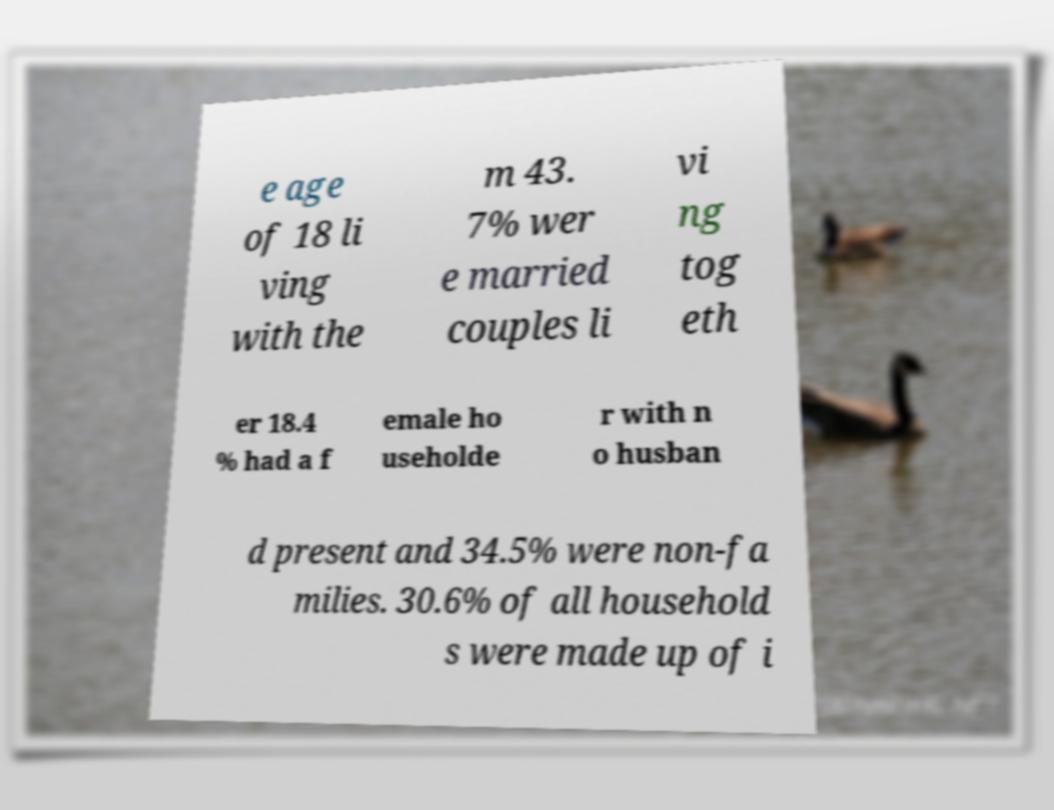Can you read and provide the text displayed in the image?This photo seems to have some interesting text. Can you extract and type it out for me? e age of 18 li ving with the m 43. 7% wer e married couples li vi ng tog eth er 18.4 % had a f emale ho useholde r with n o husban d present and 34.5% were non-fa milies. 30.6% of all household s were made up of i 